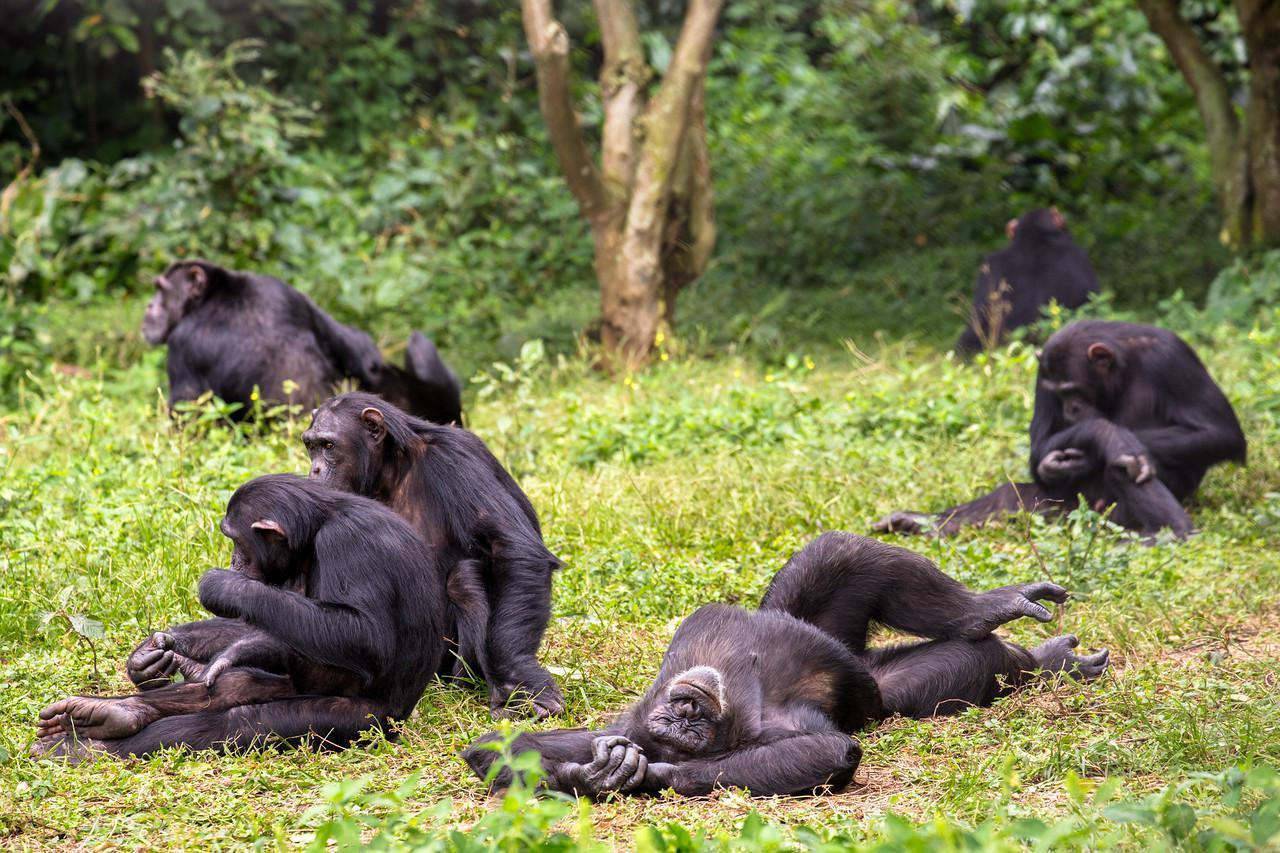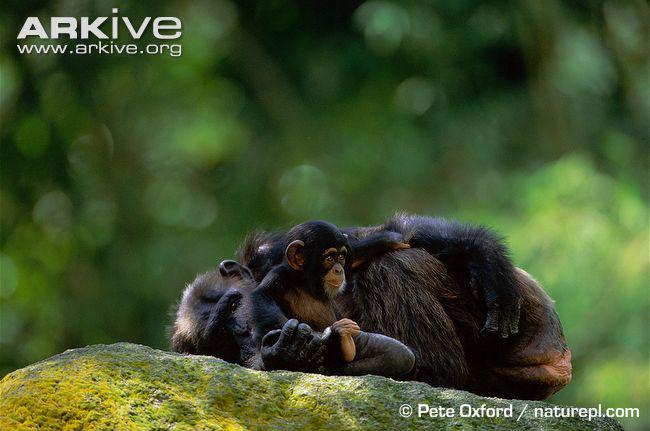The first image is the image on the left, the second image is the image on the right. For the images displayed, is the sentence "At least three primates are huddled in the image on the right." factually correct? Answer yes or no. Yes. 